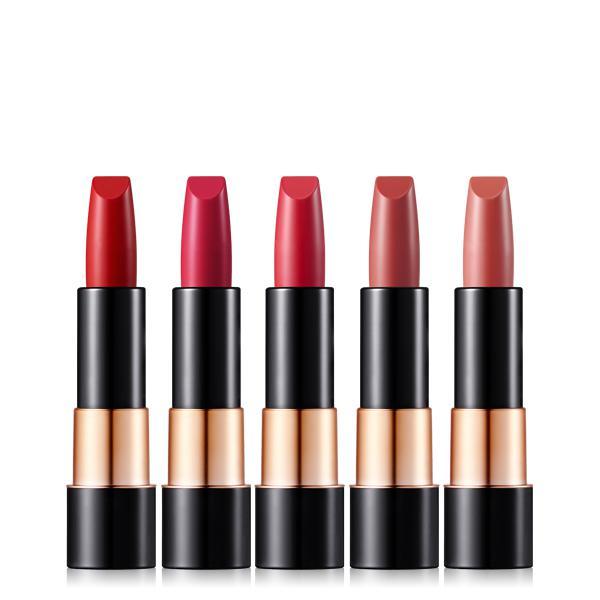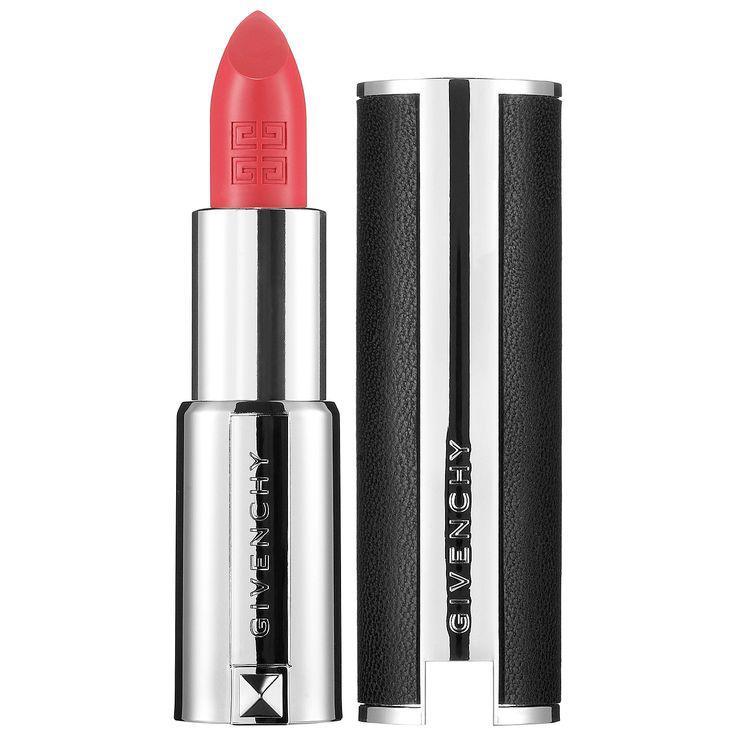The first image is the image on the left, the second image is the image on the right. Considering the images on both sides, is "One image shows exactly five available shades of lipstick." valid? Answer yes or no. Yes. The first image is the image on the left, the second image is the image on the right. Analyze the images presented: Is the assertion "There are more lipsticks on the right than on the left image." valid? Answer yes or no. No. The first image is the image on the left, the second image is the image on the right. Evaluate the accuracy of this statement regarding the images: "There are at least six lipsticks in the image on the right.". Is it true? Answer yes or no. No. 